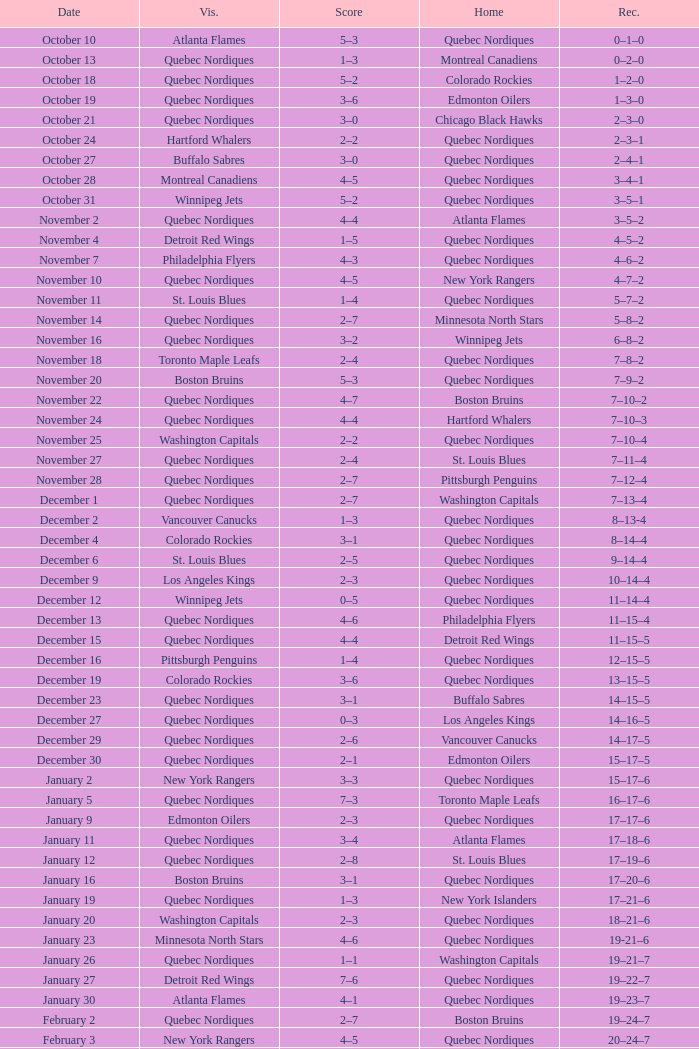Which Date has a Score of 2–7, and a Record of 5–8–2? November 14. 